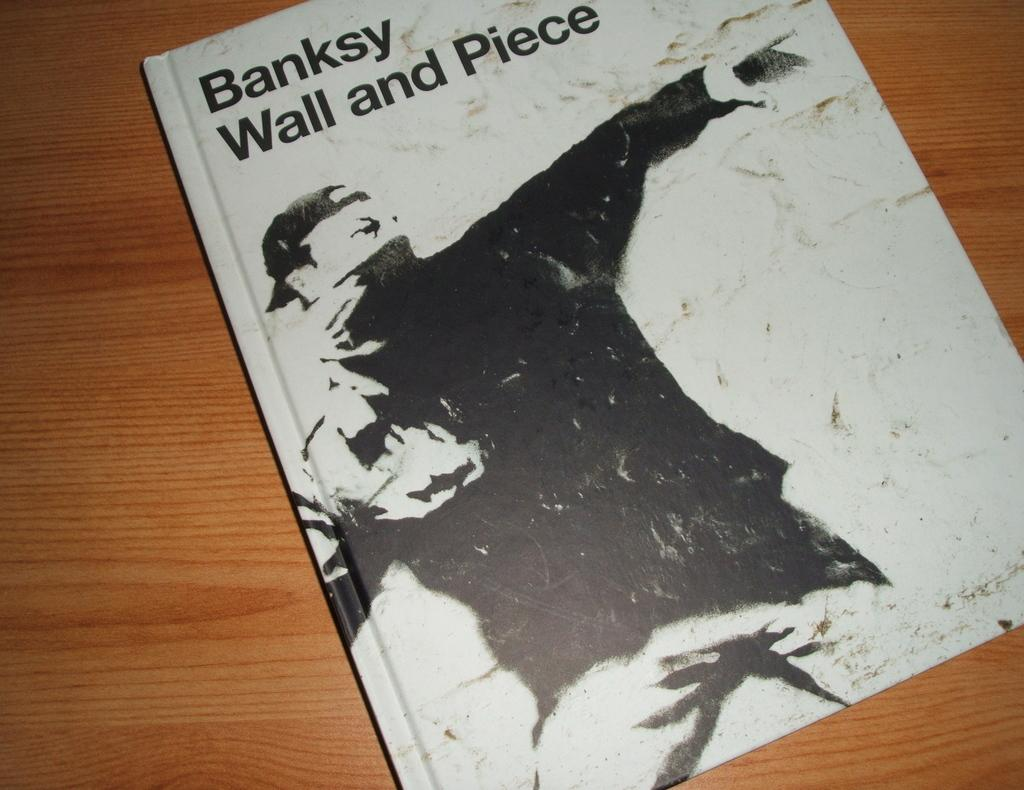<image>
Summarize the visual content of the image. a book cover that is titled 'banksy wall and piece' 